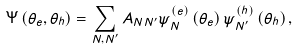Convert formula to latex. <formula><loc_0><loc_0><loc_500><loc_500>\Psi \left ( \theta _ { e } , \theta _ { h } \right ) = \sum _ { N , N ^ { \prime } } A _ { N N ^ { \prime } } \psi ^ { \left ( e \right ) } _ { N } \left ( \theta _ { e } \right ) \psi ^ { \left ( h \right ) } _ { N ^ { \prime } } \left ( \theta _ { h } \right ) ,</formula> 